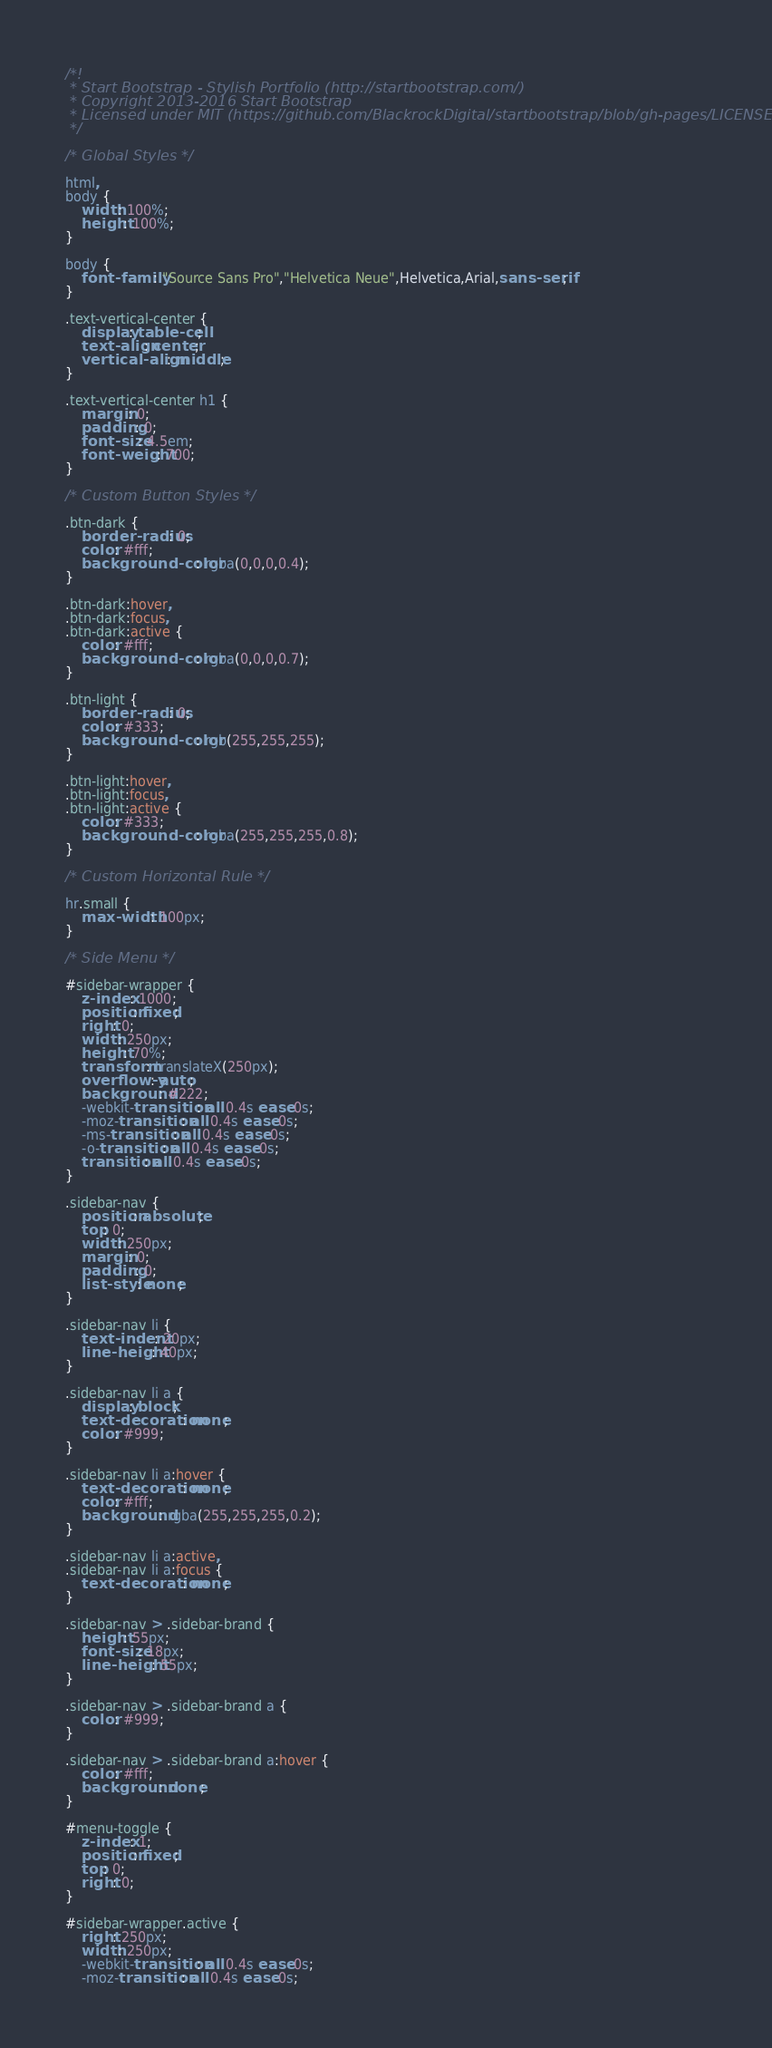<code> <loc_0><loc_0><loc_500><loc_500><_CSS_>/*!
 * Start Bootstrap - Stylish Portfolio (http://startbootstrap.com/)
 * Copyright 2013-2016 Start Bootstrap
 * Licensed under MIT (https://github.com/BlackrockDigital/startbootstrap/blob/gh-pages/LICENSE)
 */

/* Global Styles */

html,
body {
    width: 100%;
    height: 100%;
}

body {
    font-family: "Source Sans Pro","Helvetica Neue",Helvetica,Arial,sans-serif;
}

.text-vertical-center {
    display: table-cell;
    text-align: center;
    vertical-align: middle;
}

.text-vertical-center h1 {
    margin: 0;
    padding: 0;
    font-size: 4.5em;
    font-weight: 700;
}

/* Custom Button Styles */

.btn-dark {
    border-radius: 0;
    color: #fff;
    background-color: rgba(0,0,0,0.4);
}

.btn-dark:hover,
.btn-dark:focus,
.btn-dark:active {
    color: #fff;
    background-color: rgba(0,0,0,0.7);
}

.btn-light {
    border-radius: 0;
    color: #333;
    background-color: rgb(255,255,255);
}

.btn-light:hover,
.btn-light:focus,
.btn-light:active {
    color: #333;
    background-color: rgba(255,255,255,0.8);
}

/* Custom Horizontal Rule */

hr.small {
    max-width: 100px;
}

/* Side Menu */

#sidebar-wrapper {
    z-index: 1000;
    position: fixed;
    right: 0;
    width: 250px;
    height: 70%;
    transform: translateX(250px);
    overflow-y: auto;
    background: #222;
    -webkit-transition: all 0.4s ease 0s;
    -moz-transition: all 0.4s ease 0s;
    -ms-transition: all 0.4s ease 0s;
    -o-transition: all 0.4s ease 0s;
    transition: all 0.4s ease 0s;
}

.sidebar-nav {
    position: absolute;
    top: 0;
    width: 250px;
    margin: 0;
    padding: 0;
    list-style: none;
}

.sidebar-nav li {
    text-indent: 20px;
    line-height: 40px;
}

.sidebar-nav li a {
    display: block;
    text-decoration: none;
    color: #999;
}

.sidebar-nav li a:hover {
    text-decoration: none;
    color: #fff;
    background: rgba(255,255,255,0.2);
}

.sidebar-nav li a:active,
.sidebar-nav li a:focus {
    text-decoration: none;
}

.sidebar-nav > .sidebar-brand {
    height: 55px;
    font-size: 18px;
    line-height: 55px;
}

.sidebar-nav > .sidebar-brand a {
    color: #999;
}

.sidebar-nav > .sidebar-brand a:hover {
    color: #fff;
    background: none;
}

#menu-toggle {
    z-index: 1;
    position: fixed;
    top: 0;
    right: 0;
}

#sidebar-wrapper.active {
    right: 250px;
    width: 250px;
    -webkit-transition: all 0.4s ease 0s;
    -moz-transition: all 0.4s ease 0s;</code> 